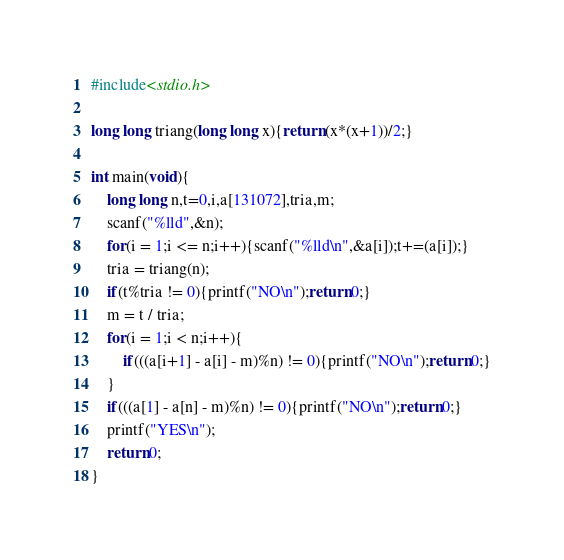Convert code to text. <code><loc_0><loc_0><loc_500><loc_500><_C_>#include<stdio.h>

long long triang(long long x){return (x*(x+1))/2;}

int main(void){
	long long n,t=0,i,a[131072],tria,m;
	scanf("%lld",&n);
	for(i = 1;i <= n;i++){scanf("%lld\n",&a[i]);t+=(a[i]);}
	tria = triang(n);
	if(t%tria != 0){printf("NO\n");return 0;}
	m = t / tria;
	for(i = 1;i < n;i++){
		if(((a[i+1] - a[i] - m)%n) != 0){printf("NO\n");return 0;}
	}
	if(((a[1] - a[n] - m)%n) != 0){printf("NO\n");return 0;}
	printf("YES\n");
	return 0;
}</code> 